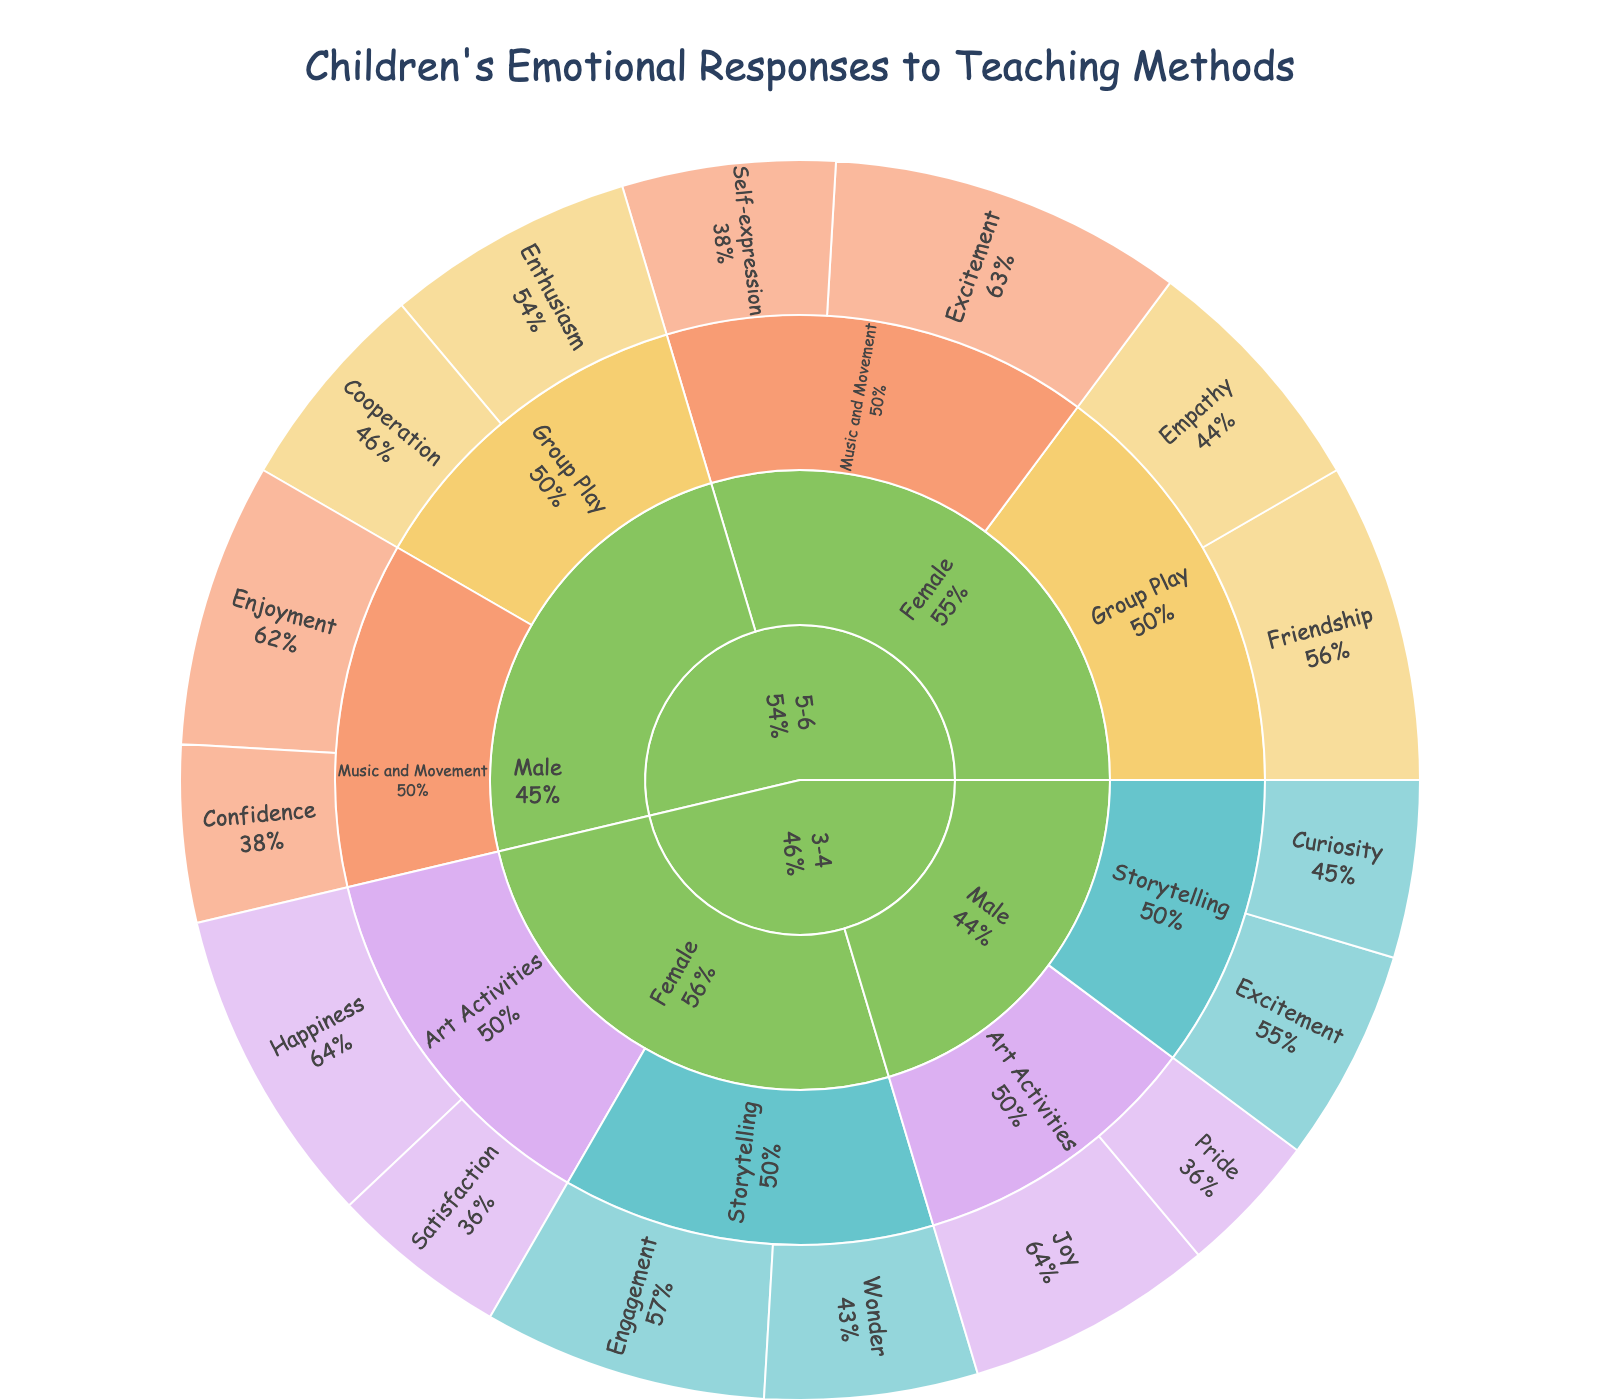What is the title of the sunburst plot? The title is located at the top center of the figure in a larger font size.
Answer: Children's Emotional Responses to Teaching Methods Which emotional response has the highest value for 5-6 year old females participating in Music and Movement activities? Observe the proportion of each emotional response within the "5-6" -> "Female" -> "Music and Movement" category. The segment with the largest area represents the highest value.
Answer: Excitement What is the combined value of all emotional responses for 3-4 year olds engaged in Art Activities? Sum the values of all emotional responses under "3-4" -> "Male" -> "Art Activities" and "3-4" -> "Female" -> "Art Activities". The values are 35 + 20 + 45 + 25.
Answer: 125 Between 5-6 year old males and 5-6 year old females, who exhibits more Enthusiasm during Group Play? Compare the area or value of the "Enthusiasm" segment under "5-6" -> "Male" -> "Group Play" with the corresponding areas under "5-6" -> "Female" -> "Group Play".
Answer: Males Which teaching method elicits the most varied emotional responses from 3-4 year old children? Look at the number of different emotional response segments within each teaching method category for 3-4 year olds and count them.
Answer: Storytelling How does the value of Happiness among 3-4 year old females in Art Activities compare to the value of Joy among 3-4 year old males in the same activity? Compare the size or value of the "Happiness" segment under "3-4" -> "Female" -> "Art Activities" to the "Joy" segment under "3-4" -> "Male" -> "Art Activities".
Answer: Larger What percentage of total emotional responses for 5-6 year old females is accounted for by Excitement during Music and Movement? Sum the values of all emotional responses for 5-6 year old females and calculate the percentage of the value for Excitement during Music and Movement. Total is 45 + 35 + 50 + 30 = 160, Excitement is 50.
Answer: 31.25% Which age group shows a more balanced emotional response distribution across different teaching methods? Compare the size of segments across teaching methods for both age groups and assess the distribution balance.
Answer: 3-4 year olds How many unique emotional responses are there for 3-4 year old males? Count the different emotional response segments listed under "3-4" -> "Male".
Answer: 4 For 5-6 year old children, which gender has a higher total value for Music and Movement activities? Sum the values of all emotional responses under "5-6" -> "Male" -> "Music and Movement" and compare it to the sum under "5-6" -> "Female" -> "Music and Movement". Values are 40 + 25 for males and 50 + 30 for females.
Answer: Females 